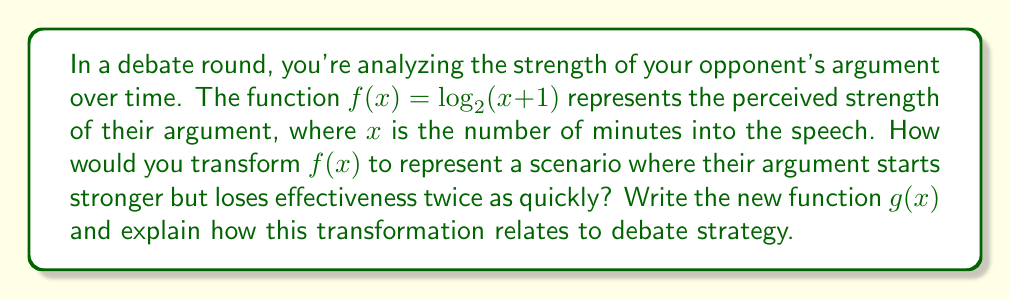Show me your answer to this math problem. To solve this problem, we need to apply multiple transformations to the original function $f(x) = \log_2(x+1)$. Let's break it down step by step:

1) First, we want the argument to start stronger. This means we need to shift the function up vertically. Let's say we shift it up by 2 units. This transformation is represented by adding 2 to the function:

   $f_1(x) = \log_2(x+1) + 2$

2) Next, we want the argument to lose effectiveness twice as quickly. This means we need to compress the function horizontally by a factor of 2. We can achieve this by multiplying $x$ by 2 inside the function:

   $f_2(x) = \log_2(2x+1) + 2$

3) Combining these transformations gives us our final function $g(x)$:

   $g(x) = \log_2(2x+1) + 2$

In terms of debate strategy, this transformation represents a scenario where:

- The vertical shift (+2) indicates that the argument starts from a stronger position, perhaps due to a compelling opening statement or strong initial evidence.

- The horizontal compression (2x) shows that the effectiveness of the argument decreases more rapidly over time. This could represent a situation where the opponent's argument is front-loaded and loses impact as the debate progresses, perhaps due to lack of substantiation or effective counterarguments.

Understanding these transformations can help a debater anticipate and respond to different argument structures. For instance, recognizing a "front-loaded" argument might prompt a debater to focus on dismantling key points early or to emphasize the lack of sustained reasoning in their rebuttal.
Answer: $g(x) = \log_2(2x+1) + 2$ 